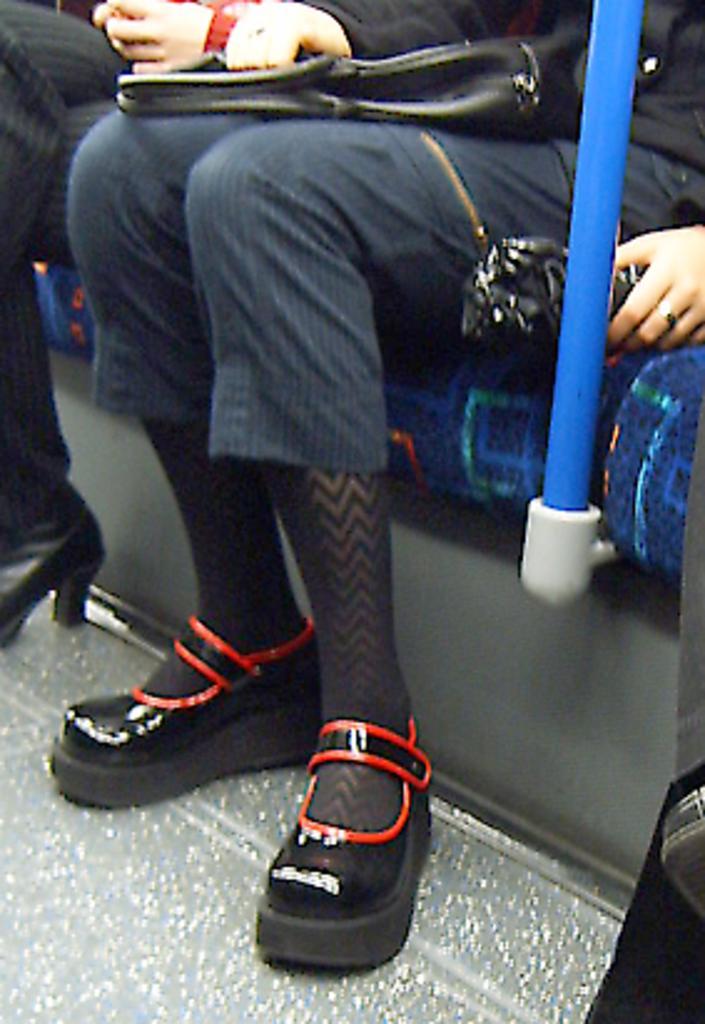Can you describe this image briefly? In this image there are legs of the person which are in the center visible and there are hands. In the front there is a person sitting and there is a bag on the lap of the person and there is a blue colour pole. 